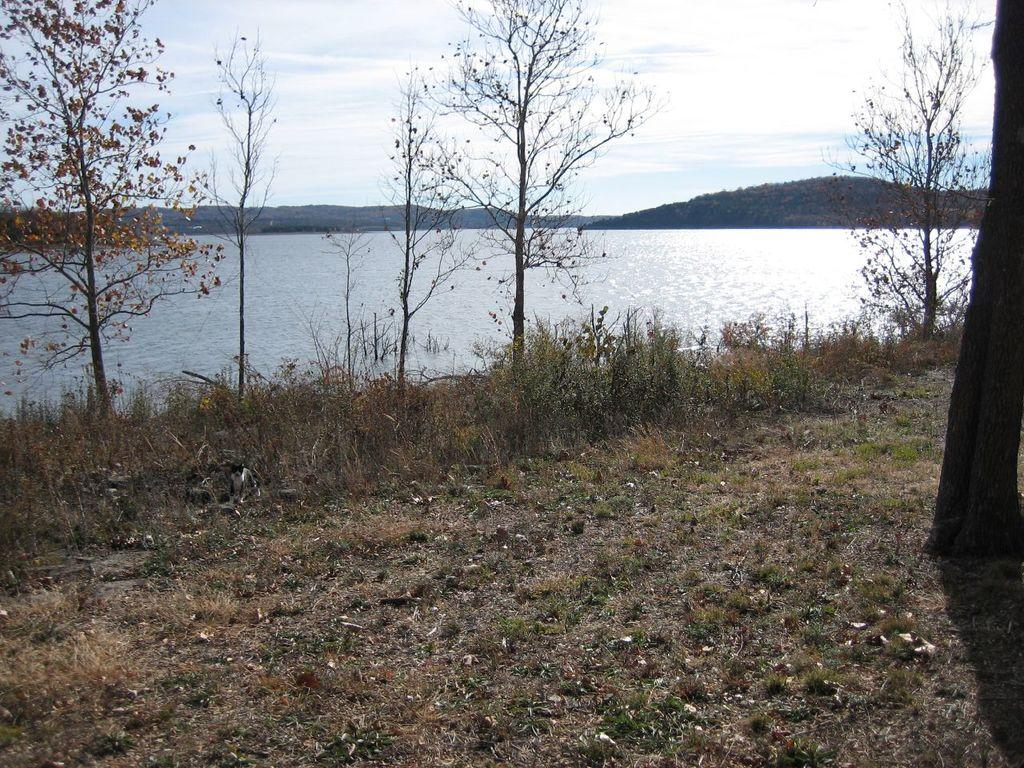What type of vegetation can be seen in the image? There is grass, plants, and trees visible in the image. Can you describe the bark of a tree in the image? Yes, the bark of a tree is visible in the image. What is visible in the background of the image? There is a water body, hills, and the sky visible in the background of the image. How would you describe the sky in the image? The sky appears cloudy in the image. What type of disgust can be seen on the plants in the image? There is no indication of disgust in the image, as plants do not have emotions or expressions. 